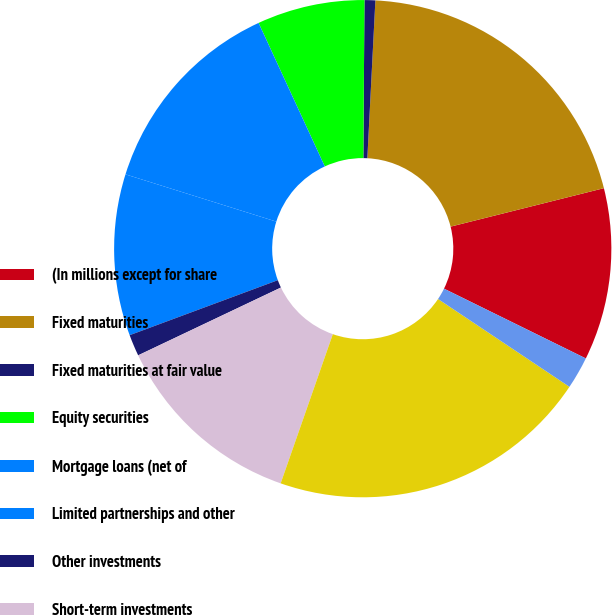<chart> <loc_0><loc_0><loc_500><loc_500><pie_chart><fcel>(In millions except for share<fcel>Fixed maturities<fcel>Fixed maturities at fair value<fcel>Equity securities<fcel>Mortgage loans (net of<fcel>Limited partnerships and other<fcel>Other investments<fcel>Short-term investments<fcel>Total investments<fcel>Cash (includes variable<nl><fcel>11.19%<fcel>20.28%<fcel>0.7%<fcel>6.99%<fcel>13.29%<fcel>10.49%<fcel>1.4%<fcel>12.59%<fcel>20.98%<fcel>2.1%<nl></chart> 